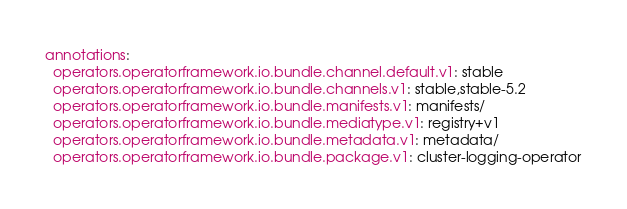Convert code to text. <code><loc_0><loc_0><loc_500><loc_500><_YAML_>annotations:
  operators.operatorframework.io.bundle.channel.default.v1: stable
  operators.operatorframework.io.bundle.channels.v1: stable,stable-5.2
  operators.operatorframework.io.bundle.manifests.v1: manifests/
  operators.operatorframework.io.bundle.mediatype.v1: registry+v1
  operators.operatorframework.io.bundle.metadata.v1: metadata/
  operators.operatorframework.io.bundle.package.v1: cluster-logging-operator
</code> 